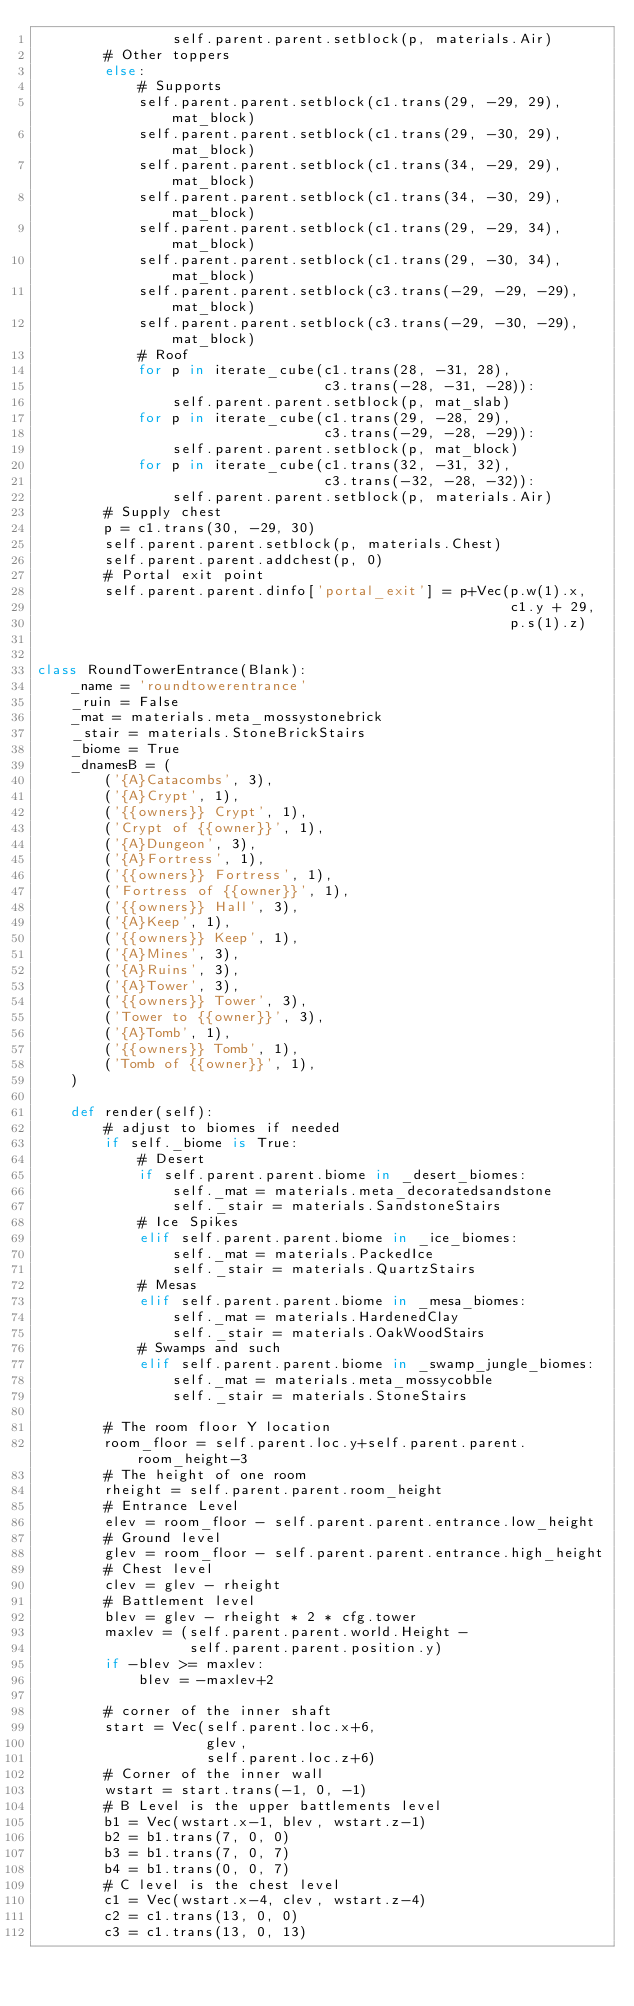<code> <loc_0><loc_0><loc_500><loc_500><_Python_>                self.parent.parent.setblock(p, materials.Air)
        # Other toppers
        else:
            # Supports
            self.parent.parent.setblock(c1.trans(29, -29, 29), mat_block)
            self.parent.parent.setblock(c1.trans(29, -30, 29), mat_block)
            self.parent.parent.setblock(c1.trans(34, -29, 29), mat_block)
            self.parent.parent.setblock(c1.trans(34, -30, 29), mat_block)
            self.parent.parent.setblock(c1.trans(29, -29, 34), mat_block)
            self.parent.parent.setblock(c1.trans(29, -30, 34), mat_block)
            self.parent.parent.setblock(c3.trans(-29, -29, -29), mat_block)
            self.parent.parent.setblock(c3.trans(-29, -30, -29), mat_block)
            # Roof
            for p in iterate_cube(c1.trans(28, -31, 28),
                                  c3.trans(-28, -31, -28)):
                self.parent.parent.setblock(p, mat_slab)
            for p in iterate_cube(c1.trans(29, -28, 29),
                                  c3.trans(-29, -28, -29)):
                self.parent.parent.setblock(p, mat_block)
            for p in iterate_cube(c1.trans(32, -31, 32),
                                  c3.trans(-32, -28, -32)):
                self.parent.parent.setblock(p, materials.Air)
        # Supply chest
        p = c1.trans(30, -29, 30)
        self.parent.parent.setblock(p, materials.Chest)
        self.parent.parent.addchest(p, 0)
        # Portal exit point
        self.parent.parent.dinfo['portal_exit'] = p+Vec(p.w(1).x,
                                                        c1.y + 29,
                                                        p.s(1).z)


class RoundTowerEntrance(Blank):
    _name = 'roundtowerentrance'
    _ruin = False
    _mat = materials.meta_mossystonebrick
    _stair = materials.StoneBrickStairs
    _biome = True
    _dnamesB = (
        ('{A}Catacombs', 3),
        ('{A}Crypt', 1),
        ('{{owners}} Crypt', 1),
        ('Crypt of {{owner}}', 1),
        ('{A}Dungeon', 3),
        ('{A}Fortress', 1),
        ('{{owners}} Fortress', 1),
        ('Fortress of {{owner}}', 1),
        ('{{owners}} Hall', 3),
        ('{A}Keep', 1),
        ('{{owners}} Keep', 1),
        ('{A}Mines', 3),
        ('{A}Ruins', 3),
        ('{A}Tower', 3),
        ('{{owners}} Tower', 3),
        ('Tower to {{owner}}', 3),
        ('{A}Tomb', 1),
        ('{{owners}} Tomb', 1),
        ('Tomb of {{owner}}', 1),
    )

    def render(self):
        # adjust to biomes if needed
        if self._biome is True:
            # Desert
            if self.parent.parent.biome in _desert_biomes:
                self._mat = materials.meta_decoratedsandstone
                self._stair = materials.SandstoneStairs
            # Ice Spikes
            elif self.parent.parent.biome in _ice_biomes:
                self._mat = materials.PackedIce
                self._stair = materials.QuartzStairs
            # Mesas
            elif self.parent.parent.biome in _mesa_biomes:
                self._mat = materials.HardenedClay
                self._stair = materials.OakWoodStairs
            # Swamps and such
            elif self.parent.parent.biome in _swamp_jungle_biomes:
                self._mat = materials.meta_mossycobble
                self._stair = materials.StoneStairs

        # The room floor Y location
        room_floor = self.parent.loc.y+self.parent.parent.room_height-3
        # The height of one room
        rheight = self.parent.parent.room_height
        # Entrance Level
        elev = room_floor - self.parent.parent.entrance.low_height
        # Ground level
        glev = room_floor - self.parent.parent.entrance.high_height
        # Chest level
        clev = glev - rheight
        # Battlement level
        blev = glev - rheight * 2 * cfg.tower
        maxlev = (self.parent.parent.world.Height -
                  self.parent.parent.position.y)
        if -blev >= maxlev:
            blev = -maxlev+2

        # corner of the inner shaft
        start = Vec(self.parent.loc.x+6,
                    glev,
                    self.parent.loc.z+6)
        # Corner of the inner wall
        wstart = start.trans(-1, 0, -1)
        # B Level is the upper battlements level
        b1 = Vec(wstart.x-1, blev, wstart.z-1)
        b2 = b1.trans(7, 0, 0)
        b3 = b1.trans(7, 0, 7)
        b4 = b1.trans(0, 0, 7)
        # C level is the chest level
        c1 = Vec(wstart.x-4, clev, wstart.z-4)
        c2 = c1.trans(13, 0, 0)
        c3 = c1.trans(13, 0, 13)</code> 